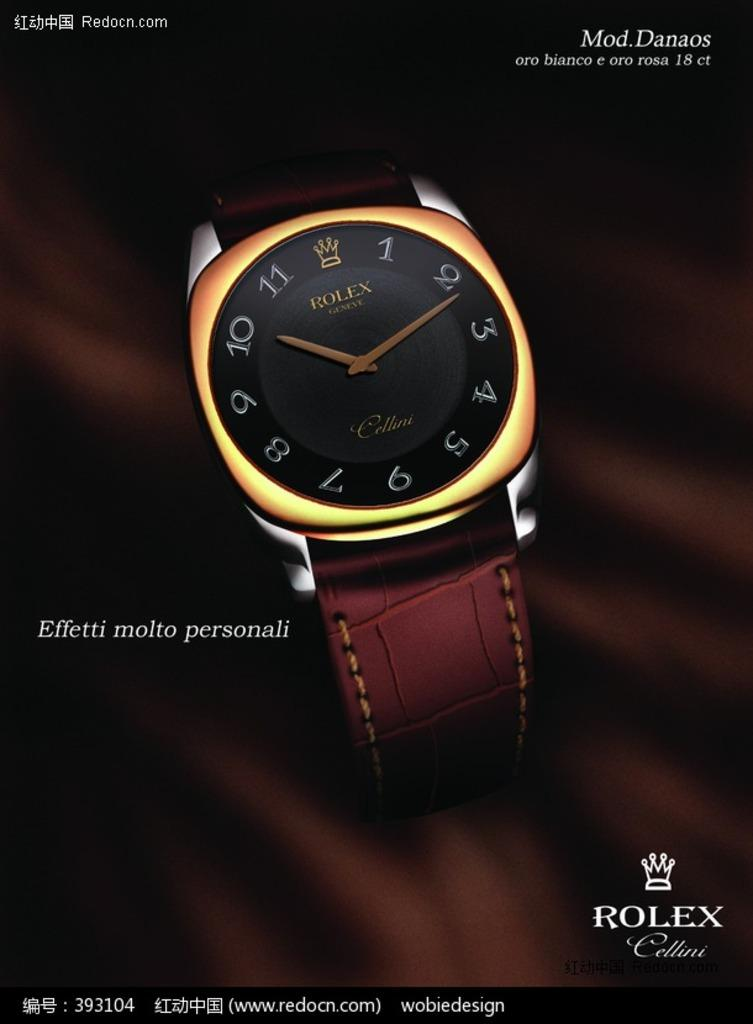<image>
Share a concise interpretation of the image provided. An advertisement for Rolex shows a watch with a leather band. 